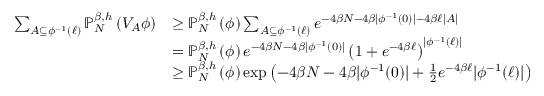Convert formula to latex. <formula><loc_0><loc_0><loc_500><loc_500>\begin{array} { r l } { \sum _ { A \subseteq \phi ^ { - 1 } ( \ell ) } { { \mathbb { P } } } _ { N } ^ { \beta , h } \left ( V _ { A } \phi \right ) } & { \geq { { \mathbb { P } } } _ { N } ^ { \beta , h } \left ( \phi \right ) \sum _ { A \subseteq \phi ^ { - 1 } ( \ell ) } e ^ { - 4 \beta N - 4 \beta | \phi ^ { - 1 } ( 0 ) | - 4 \beta \ell | A | } } \\ & { = { { \mathbb { P } } } _ { N } ^ { \beta , h } \left ( \phi \right ) e ^ { - 4 \beta N - 4 \beta | \phi ^ { - 1 } ( 0 ) | } \left ( 1 + e ^ { - 4 \beta \ell } \right ) ^ { | \phi ^ { - 1 } ( \ell ) | } } \\ & { \geq { { \mathbb { P } } } _ { N } ^ { \beta , h } \left ( \phi \right ) \exp \left ( - 4 \beta N - 4 \beta | \phi ^ { - 1 } ( 0 ) | + \frac { 1 } { 2 } e ^ { - 4 \beta \ell } | \phi ^ { - 1 } ( \ell ) | \right ) } \end{array}</formula> 